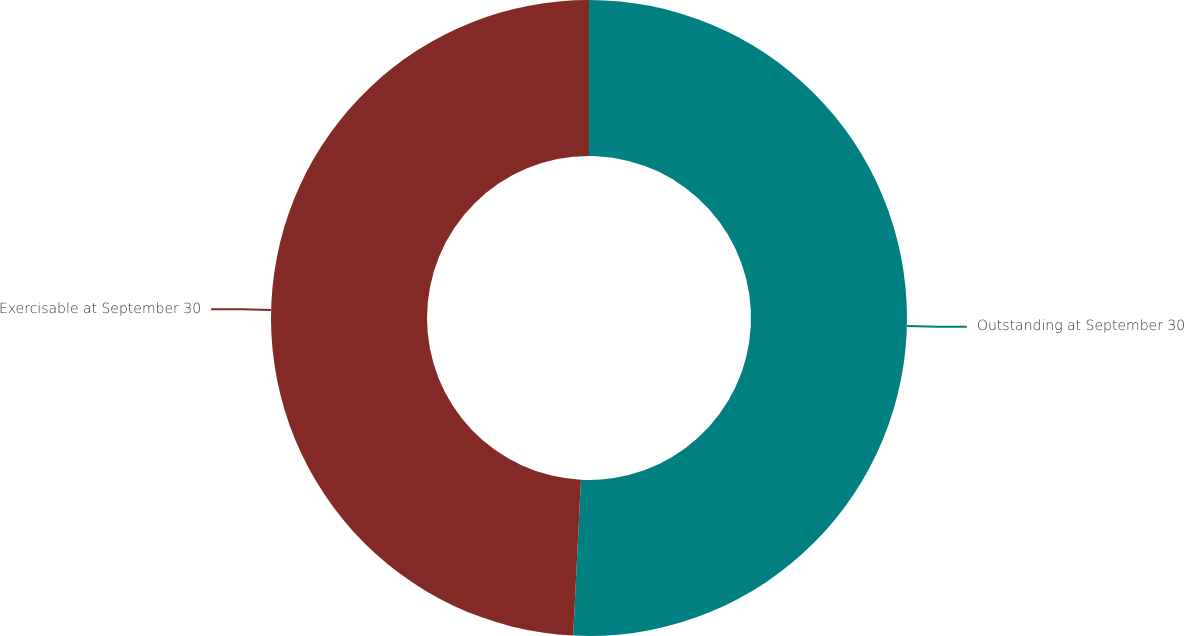Convert chart. <chart><loc_0><loc_0><loc_500><loc_500><pie_chart><fcel>Outstanding at September 30<fcel>Exercisable at September 30<nl><fcel>50.79%<fcel>49.21%<nl></chart> 